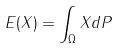Convert formula to latex. <formula><loc_0><loc_0><loc_500><loc_500>E ( X ) = \int _ { \Omega } X d P</formula> 